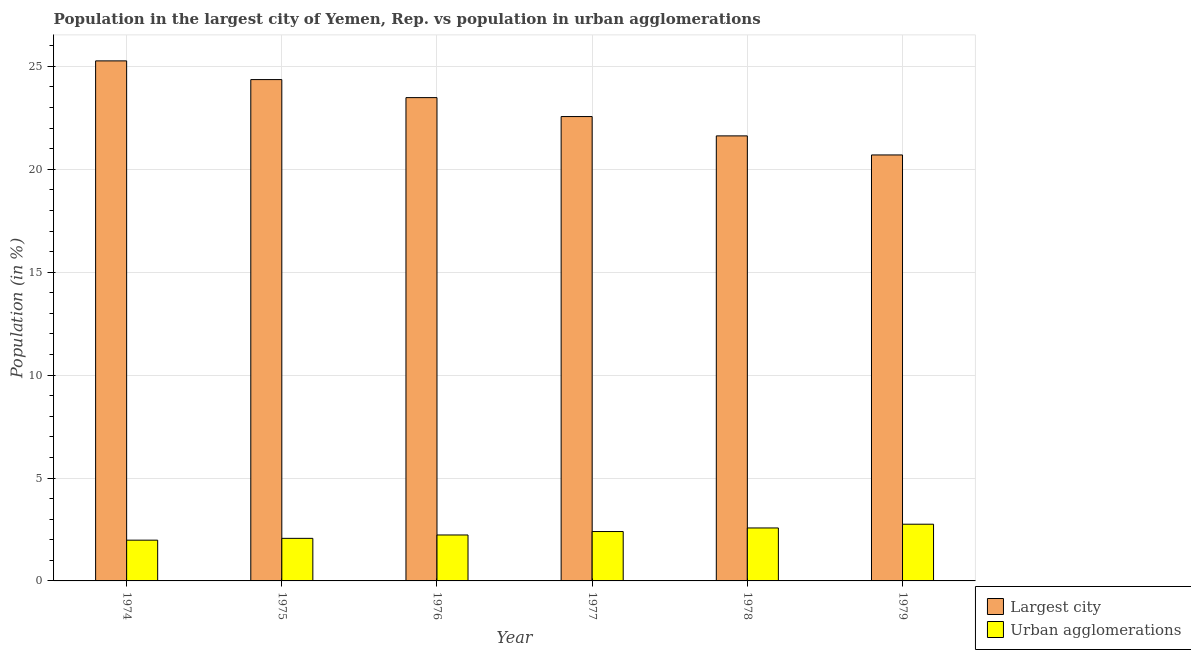How many different coloured bars are there?
Your answer should be compact. 2. Are the number of bars per tick equal to the number of legend labels?
Give a very brief answer. Yes. How many bars are there on the 4th tick from the left?
Make the answer very short. 2. How many bars are there on the 2nd tick from the right?
Ensure brevity in your answer.  2. What is the label of the 2nd group of bars from the left?
Your response must be concise. 1975. What is the population in urban agglomerations in 1978?
Give a very brief answer. 2.57. Across all years, what is the maximum population in urban agglomerations?
Your response must be concise. 2.76. Across all years, what is the minimum population in the largest city?
Offer a very short reply. 20.7. In which year was the population in the largest city maximum?
Provide a short and direct response. 1974. In which year was the population in urban agglomerations minimum?
Ensure brevity in your answer.  1974. What is the total population in urban agglomerations in the graph?
Provide a succinct answer. 14.01. What is the difference between the population in urban agglomerations in 1977 and that in 1979?
Your answer should be compact. -0.36. What is the difference between the population in urban agglomerations in 1974 and the population in the largest city in 1975?
Your response must be concise. -0.09. What is the average population in urban agglomerations per year?
Your answer should be very brief. 2.33. In the year 1977, what is the difference between the population in urban agglomerations and population in the largest city?
Give a very brief answer. 0. In how many years, is the population in the largest city greater than 20 %?
Make the answer very short. 6. What is the ratio of the population in the largest city in 1977 to that in 1978?
Your answer should be very brief. 1.04. Is the population in urban agglomerations in 1976 less than that in 1977?
Ensure brevity in your answer.  Yes. What is the difference between the highest and the second highest population in the largest city?
Provide a short and direct response. 0.91. What is the difference between the highest and the lowest population in the largest city?
Offer a very short reply. 4.57. In how many years, is the population in urban agglomerations greater than the average population in urban agglomerations taken over all years?
Provide a short and direct response. 3. Is the sum of the population in urban agglomerations in 1978 and 1979 greater than the maximum population in the largest city across all years?
Provide a short and direct response. Yes. What does the 1st bar from the left in 1975 represents?
Your answer should be very brief. Largest city. What does the 2nd bar from the right in 1978 represents?
Keep it short and to the point. Largest city. How many bars are there?
Your answer should be very brief. 12. How many years are there in the graph?
Ensure brevity in your answer.  6. What is the difference between two consecutive major ticks on the Y-axis?
Give a very brief answer. 5. Does the graph contain any zero values?
Your response must be concise. No. Does the graph contain grids?
Offer a terse response. Yes. How many legend labels are there?
Offer a terse response. 2. What is the title of the graph?
Your response must be concise. Population in the largest city of Yemen, Rep. vs population in urban agglomerations. Does "Primary income" appear as one of the legend labels in the graph?
Your answer should be compact. No. What is the label or title of the Y-axis?
Your response must be concise. Population (in %). What is the Population (in %) in Largest city in 1974?
Provide a succinct answer. 25.27. What is the Population (in %) of Urban agglomerations in 1974?
Offer a very short reply. 1.98. What is the Population (in %) in Largest city in 1975?
Offer a terse response. 24.36. What is the Population (in %) of Urban agglomerations in 1975?
Your answer should be compact. 2.07. What is the Population (in %) in Largest city in 1976?
Provide a short and direct response. 23.48. What is the Population (in %) in Urban agglomerations in 1976?
Ensure brevity in your answer.  2.23. What is the Population (in %) of Largest city in 1977?
Provide a short and direct response. 22.56. What is the Population (in %) in Urban agglomerations in 1977?
Your response must be concise. 2.4. What is the Population (in %) in Largest city in 1978?
Your answer should be very brief. 21.62. What is the Population (in %) in Urban agglomerations in 1978?
Offer a very short reply. 2.57. What is the Population (in %) in Largest city in 1979?
Your answer should be compact. 20.7. What is the Population (in %) of Urban agglomerations in 1979?
Offer a very short reply. 2.76. Across all years, what is the maximum Population (in %) of Largest city?
Give a very brief answer. 25.27. Across all years, what is the maximum Population (in %) in Urban agglomerations?
Provide a succinct answer. 2.76. Across all years, what is the minimum Population (in %) in Largest city?
Keep it short and to the point. 20.7. Across all years, what is the minimum Population (in %) in Urban agglomerations?
Offer a terse response. 1.98. What is the total Population (in %) in Largest city in the graph?
Your answer should be very brief. 138. What is the total Population (in %) in Urban agglomerations in the graph?
Give a very brief answer. 14.01. What is the difference between the Population (in %) of Largest city in 1974 and that in 1975?
Your response must be concise. 0.91. What is the difference between the Population (in %) in Urban agglomerations in 1974 and that in 1975?
Give a very brief answer. -0.09. What is the difference between the Population (in %) of Largest city in 1974 and that in 1976?
Provide a short and direct response. 1.79. What is the difference between the Population (in %) in Urban agglomerations in 1974 and that in 1976?
Make the answer very short. -0.25. What is the difference between the Population (in %) of Largest city in 1974 and that in 1977?
Your answer should be compact. 2.71. What is the difference between the Population (in %) of Urban agglomerations in 1974 and that in 1977?
Provide a succinct answer. -0.42. What is the difference between the Population (in %) in Largest city in 1974 and that in 1978?
Your answer should be very brief. 3.64. What is the difference between the Population (in %) of Urban agglomerations in 1974 and that in 1978?
Provide a short and direct response. -0.59. What is the difference between the Population (in %) of Largest city in 1974 and that in 1979?
Ensure brevity in your answer.  4.57. What is the difference between the Population (in %) of Urban agglomerations in 1974 and that in 1979?
Provide a succinct answer. -0.77. What is the difference between the Population (in %) in Largest city in 1975 and that in 1976?
Provide a short and direct response. 0.88. What is the difference between the Population (in %) in Urban agglomerations in 1975 and that in 1976?
Keep it short and to the point. -0.16. What is the difference between the Population (in %) in Largest city in 1975 and that in 1977?
Give a very brief answer. 1.8. What is the difference between the Population (in %) in Urban agglomerations in 1975 and that in 1977?
Provide a short and direct response. -0.33. What is the difference between the Population (in %) in Largest city in 1975 and that in 1978?
Make the answer very short. 2.74. What is the difference between the Population (in %) in Urban agglomerations in 1975 and that in 1978?
Give a very brief answer. -0.5. What is the difference between the Population (in %) in Largest city in 1975 and that in 1979?
Your response must be concise. 3.66. What is the difference between the Population (in %) in Urban agglomerations in 1975 and that in 1979?
Provide a short and direct response. -0.69. What is the difference between the Population (in %) of Largest city in 1976 and that in 1977?
Keep it short and to the point. 0.92. What is the difference between the Population (in %) of Urban agglomerations in 1976 and that in 1977?
Your response must be concise. -0.17. What is the difference between the Population (in %) of Largest city in 1976 and that in 1978?
Ensure brevity in your answer.  1.86. What is the difference between the Population (in %) of Urban agglomerations in 1976 and that in 1978?
Provide a succinct answer. -0.34. What is the difference between the Population (in %) of Largest city in 1976 and that in 1979?
Offer a terse response. 2.79. What is the difference between the Population (in %) in Urban agglomerations in 1976 and that in 1979?
Your response must be concise. -0.52. What is the difference between the Population (in %) of Largest city in 1977 and that in 1978?
Keep it short and to the point. 0.94. What is the difference between the Population (in %) of Urban agglomerations in 1977 and that in 1978?
Your answer should be compact. -0.17. What is the difference between the Population (in %) of Largest city in 1977 and that in 1979?
Offer a terse response. 1.87. What is the difference between the Population (in %) of Urban agglomerations in 1977 and that in 1979?
Give a very brief answer. -0.36. What is the difference between the Population (in %) in Largest city in 1978 and that in 1979?
Ensure brevity in your answer.  0.93. What is the difference between the Population (in %) of Urban agglomerations in 1978 and that in 1979?
Offer a terse response. -0.18. What is the difference between the Population (in %) of Largest city in 1974 and the Population (in %) of Urban agglomerations in 1975?
Give a very brief answer. 23.2. What is the difference between the Population (in %) in Largest city in 1974 and the Population (in %) in Urban agglomerations in 1976?
Keep it short and to the point. 23.04. What is the difference between the Population (in %) of Largest city in 1974 and the Population (in %) of Urban agglomerations in 1977?
Make the answer very short. 22.87. What is the difference between the Population (in %) of Largest city in 1974 and the Population (in %) of Urban agglomerations in 1978?
Give a very brief answer. 22.7. What is the difference between the Population (in %) of Largest city in 1974 and the Population (in %) of Urban agglomerations in 1979?
Ensure brevity in your answer.  22.51. What is the difference between the Population (in %) of Largest city in 1975 and the Population (in %) of Urban agglomerations in 1976?
Your answer should be very brief. 22.13. What is the difference between the Population (in %) in Largest city in 1975 and the Population (in %) in Urban agglomerations in 1977?
Offer a very short reply. 21.96. What is the difference between the Population (in %) in Largest city in 1975 and the Population (in %) in Urban agglomerations in 1978?
Your answer should be very brief. 21.79. What is the difference between the Population (in %) of Largest city in 1975 and the Population (in %) of Urban agglomerations in 1979?
Provide a short and direct response. 21.6. What is the difference between the Population (in %) in Largest city in 1976 and the Population (in %) in Urban agglomerations in 1977?
Ensure brevity in your answer.  21.08. What is the difference between the Population (in %) in Largest city in 1976 and the Population (in %) in Urban agglomerations in 1978?
Give a very brief answer. 20.91. What is the difference between the Population (in %) of Largest city in 1976 and the Population (in %) of Urban agglomerations in 1979?
Offer a very short reply. 20.73. What is the difference between the Population (in %) in Largest city in 1977 and the Population (in %) in Urban agglomerations in 1978?
Provide a succinct answer. 19.99. What is the difference between the Population (in %) of Largest city in 1977 and the Population (in %) of Urban agglomerations in 1979?
Your answer should be very brief. 19.81. What is the difference between the Population (in %) in Largest city in 1978 and the Population (in %) in Urban agglomerations in 1979?
Provide a short and direct response. 18.87. What is the average Population (in %) in Largest city per year?
Your response must be concise. 23. What is the average Population (in %) in Urban agglomerations per year?
Your answer should be very brief. 2.33. In the year 1974, what is the difference between the Population (in %) in Largest city and Population (in %) in Urban agglomerations?
Offer a terse response. 23.29. In the year 1975, what is the difference between the Population (in %) of Largest city and Population (in %) of Urban agglomerations?
Offer a very short reply. 22.29. In the year 1976, what is the difference between the Population (in %) of Largest city and Population (in %) of Urban agglomerations?
Give a very brief answer. 21.25. In the year 1977, what is the difference between the Population (in %) of Largest city and Population (in %) of Urban agglomerations?
Provide a succinct answer. 20.16. In the year 1978, what is the difference between the Population (in %) in Largest city and Population (in %) in Urban agglomerations?
Provide a short and direct response. 19.05. In the year 1979, what is the difference between the Population (in %) in Largest city and Population (in %) in Urban agglomerations?
Your answer should be very brief. 17.94. What is the ratio of the Population (in %) in Largest city in 1974 to that in 1975?
Your response must be concise. 1.04. What is the ratio of the Population (in %) of Urban agglomerations in 1974 to that in 1975?
Your answer should be compact. 0.96. What is the ratio of the Population (in %) of Largest city in 1974 to that in 1976?
Your answer should be very brief. 1.08. What is the ratio of the Population (in %) of Urban agglomerations in 1974 to that in 1976?
Provide a short and direct response. 0.89. What is the ratio of the Population (in %) in Largest city in 1974 to that in 1977?
Give a very brief answer. 1.12. What is the ratio of the Population (in %) in Urban agglomerations in 1974 to that in 1977?
Provide a succinct answer. 0.83. What is the ratio of the Population (in %) of Largest city in 1974 to that in 1978?
Your answer should be very brief. 1.17. What is the ratio of the Population (in %) of Urban agglomerations in 1974 to that in 1978?
Give a very brief answer. 0.77. What is the ratio of the Population (in %) of Largest city in 1974 to that in 1979?
Ensure brevity in your answer.  1.22. What is the ratio of the Population (in %) in Urban agglomerations in 1974 to that in 1979?
Ensure brevity in your answer.  0.72. What is the ratio of the Population (in %) of Largest city in 1975 to that in 1976?
Provide a succinct answer. 1.04. What is the ratio of the Population (in %) in Urban agglomerations in 1975 to that in 1976?
Your response must be concise. 0.93. What is the ratio of the Population (in %) in Largest city in 1975 to that in 1977?
Provide a succinct answer. 1.08. What is the ratio of the Population (in %) in Urban agglomerations in 1975 to that in 1977?
Provide a short and direct response. 0.86. What is the ratio of the Population (in %) of Largest city in 1975 to that in 1978?
Make the answer very short. 1.13. What is the ratio of the Population (in %) of Urban agglomerations in 1975 to that in 1978?
Ensure brevity in your answer.  0.8. What is the ratio of the Population (in %) of Largest city in 1975 to that in 1979?
Your response must be concise. 1.18. What is the ratio of the Population (in %) of Urban agglomerations in 1975 to that in 1979?
Make the answer very short. 0.75. What is the ratio of the Population (in %) of Largest city in 1976 to that in 1977?
Give a very brief answer. 1.04. What is the ratio of the Population (in %) of Urban agglomerations in 1976 to that in 1977?
Your response must be concise. 0.93. What is the ratio of the Population (in %) of Largest city in 1976 to that in 1978?
Your answer should be compact. 1.09. What is the ratio of the Population (in %) in Urban agglomerations in 1976 to that in 1978?
Your response must be concise. 0.87. What is the ratio of the Population (in %) of Largest city in 1976 to that in 1979?
Keep it short and to the point. 1.13. What is the ratio of the Population (in %) of Urban agglomerations in 1976 to that in 1979?
Give a very brief answer. 0.81. What is the ratio of the Population (in %) of Largest city in 1977 to that in 1978?
Provide a succinct answer. 1.04. What is the ratio of the Population (in %) in Urban agglomerations in 1977 to that in 1978?
Make the answer very short. 0.93. What is the ratio of the Population (in %) of Largest city in 1977 to that in 1979?
Your answer should be compact. 1.09. What is the ratio of the Population (in %) of Urban agglomerations in 1977 to that in 1979?
Make the answer very short. 0.87. What is the ratio of the Population (in %) of Largest city in 1978 to that in 1979?
Ensure brevity in your answer.  1.04. What is the ratio of the Population (in %) in Urban agglomerations in 1978 to that in 1979?
Provide a succinct answer. 0.93. What is the difference between the highest and the second highest Population (in %) of Largest city?
Make the answer very short. 0.91. What is the difference between the highest and the second highest Population (in %) in Urban agglomerations?
Your answer should be very brief. 0.18. What is the difference between the highest and the lowest Population (in %) of Largest city?
Your answer should be very brief. 4.57. What is the difference between the highest and the lowest Population (in %) of Urban agglomerations?
Your answer should be compact. 0.77. 